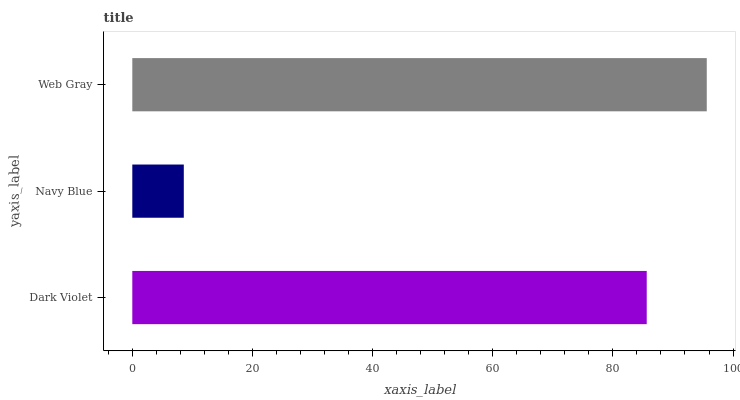Is Navy Blue the minimum?
Answer yes or no. Yes. Is Web Gray the maximum?
Answer yes or no. Yes. Is Web Gray the minimum?
Answer yes or no. No. Is Navy Blue the maximum?
Answer yes or no. No. Is Web Gray greater than Navy Blue?
Answer yes or no. Yes. Is Navy Blue less than Web Gray?
Answer yes or no. Yes. Is Navy Blue greater than Web Gray?
Answer yes or no. No. Is Web Gray less than Navy Blue?
Answer yes or no. No. Is Dark Violet the high median?
Answer yes or no. Yes. Is Dark Violet the low median?
Answer yes or no. Yes. Is Web Gray the high median?
Answer yes or no. No. Is Navy Blue the low median?
Answer yes or no. No. 